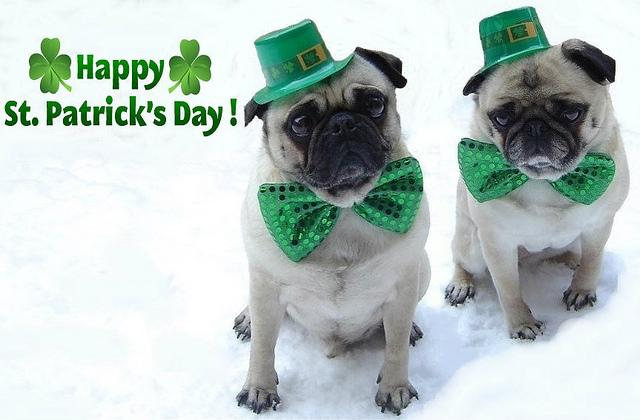What nationality is associated with the holiday being celebrated here? irish 